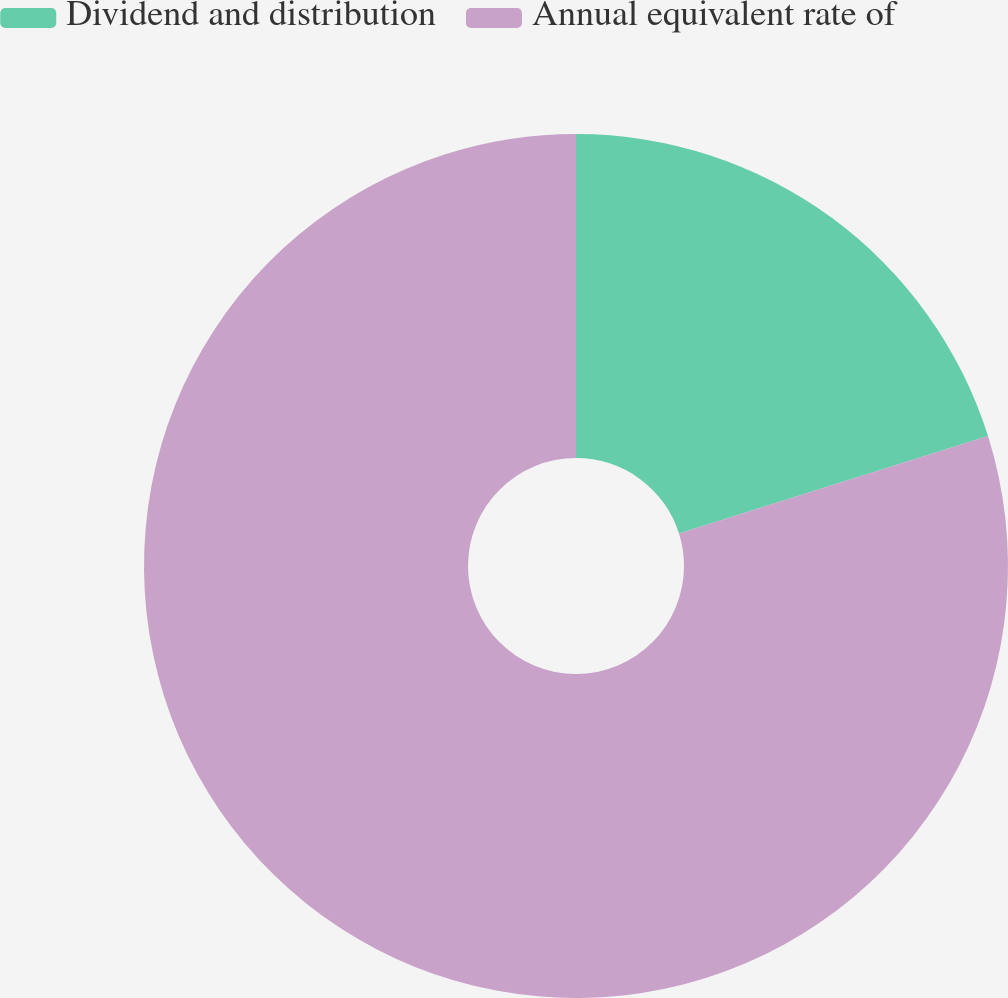Convert chart. <chart><loc_0><loc_0><loc_500><loc_500><pie_chart><fcel>Dividend and distribution<fcel>Annual equivalent rate of<nl><fcel>20.14%<fcel>79.86%<nl></chart> 